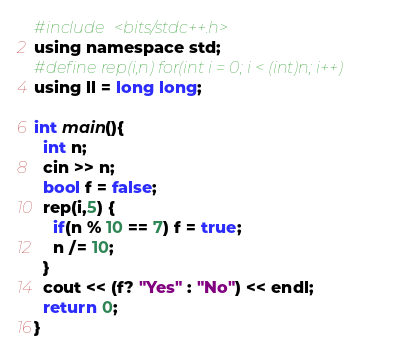<code> <loc_0><loc_0><loc_500><loc_500><_C_>#include <bits/stdc++.h>
using namespace std;
#define rep(i,n) for(int i = 0; i < (int)n; i++)
using ll = long long;

int main(){
  int n;
  cin >> n;
  bool f = false;
  rep(i,5) {
    if(n % 10 == 7) f = true;
    n /= 10;
  }
  cout << (f? "Yes" : "No") << endl;
  return 0;
}
</code> 